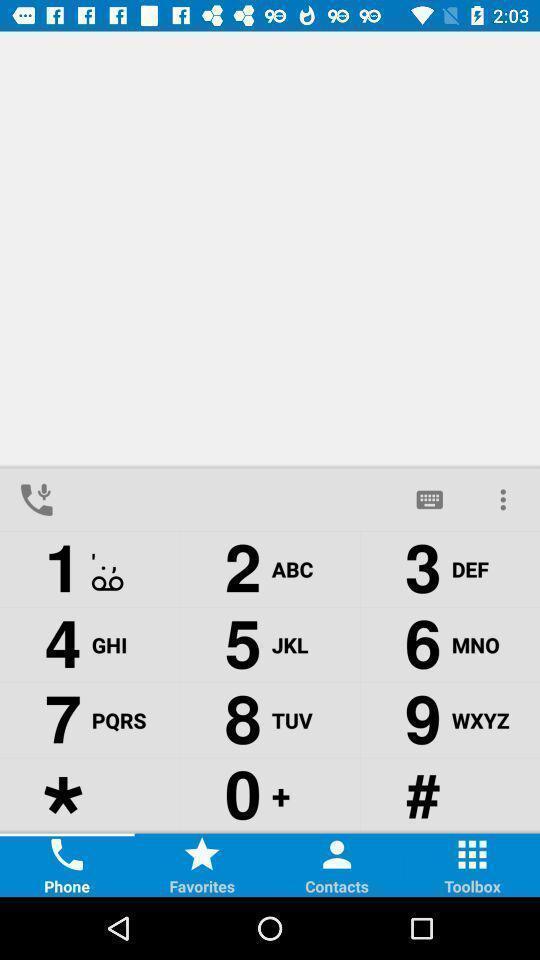Provide a textual representation of this image. Window displaying the keypad page. 